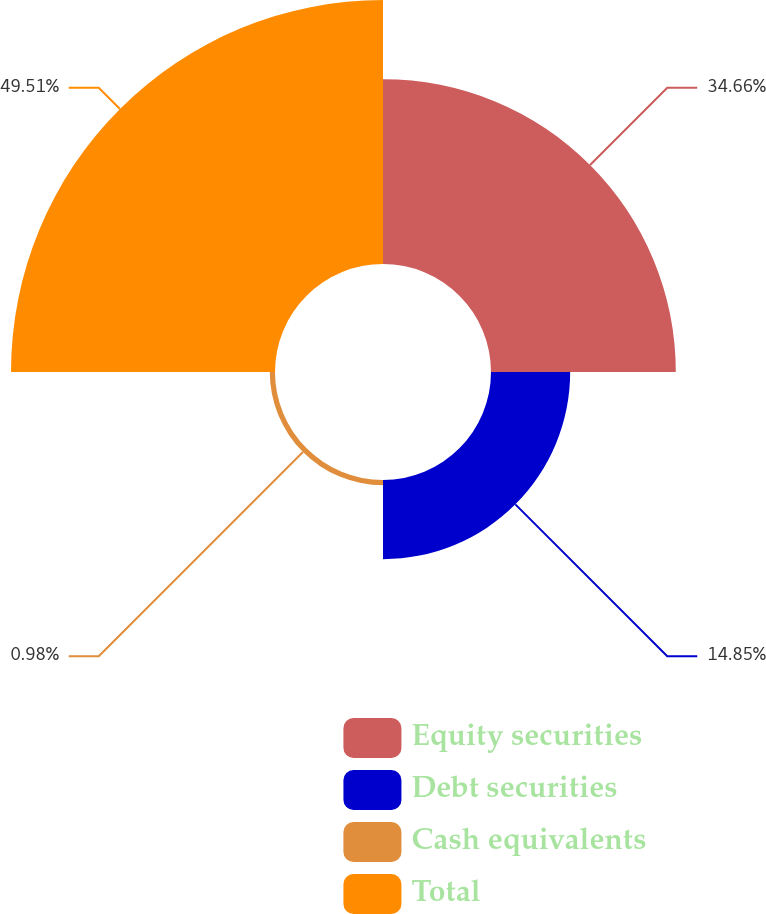Convert chart. <chart><loc_0><loc_0><loc_500><loc_500><pie_chart><fcel>Equity securities<fcel>Debt securities<fcel>Cash equivalents<fcel>Total<nl><fcel>34.66%<fcel>14.85%<fcel>0.98%<fcel>49.51%<nl></chart> 